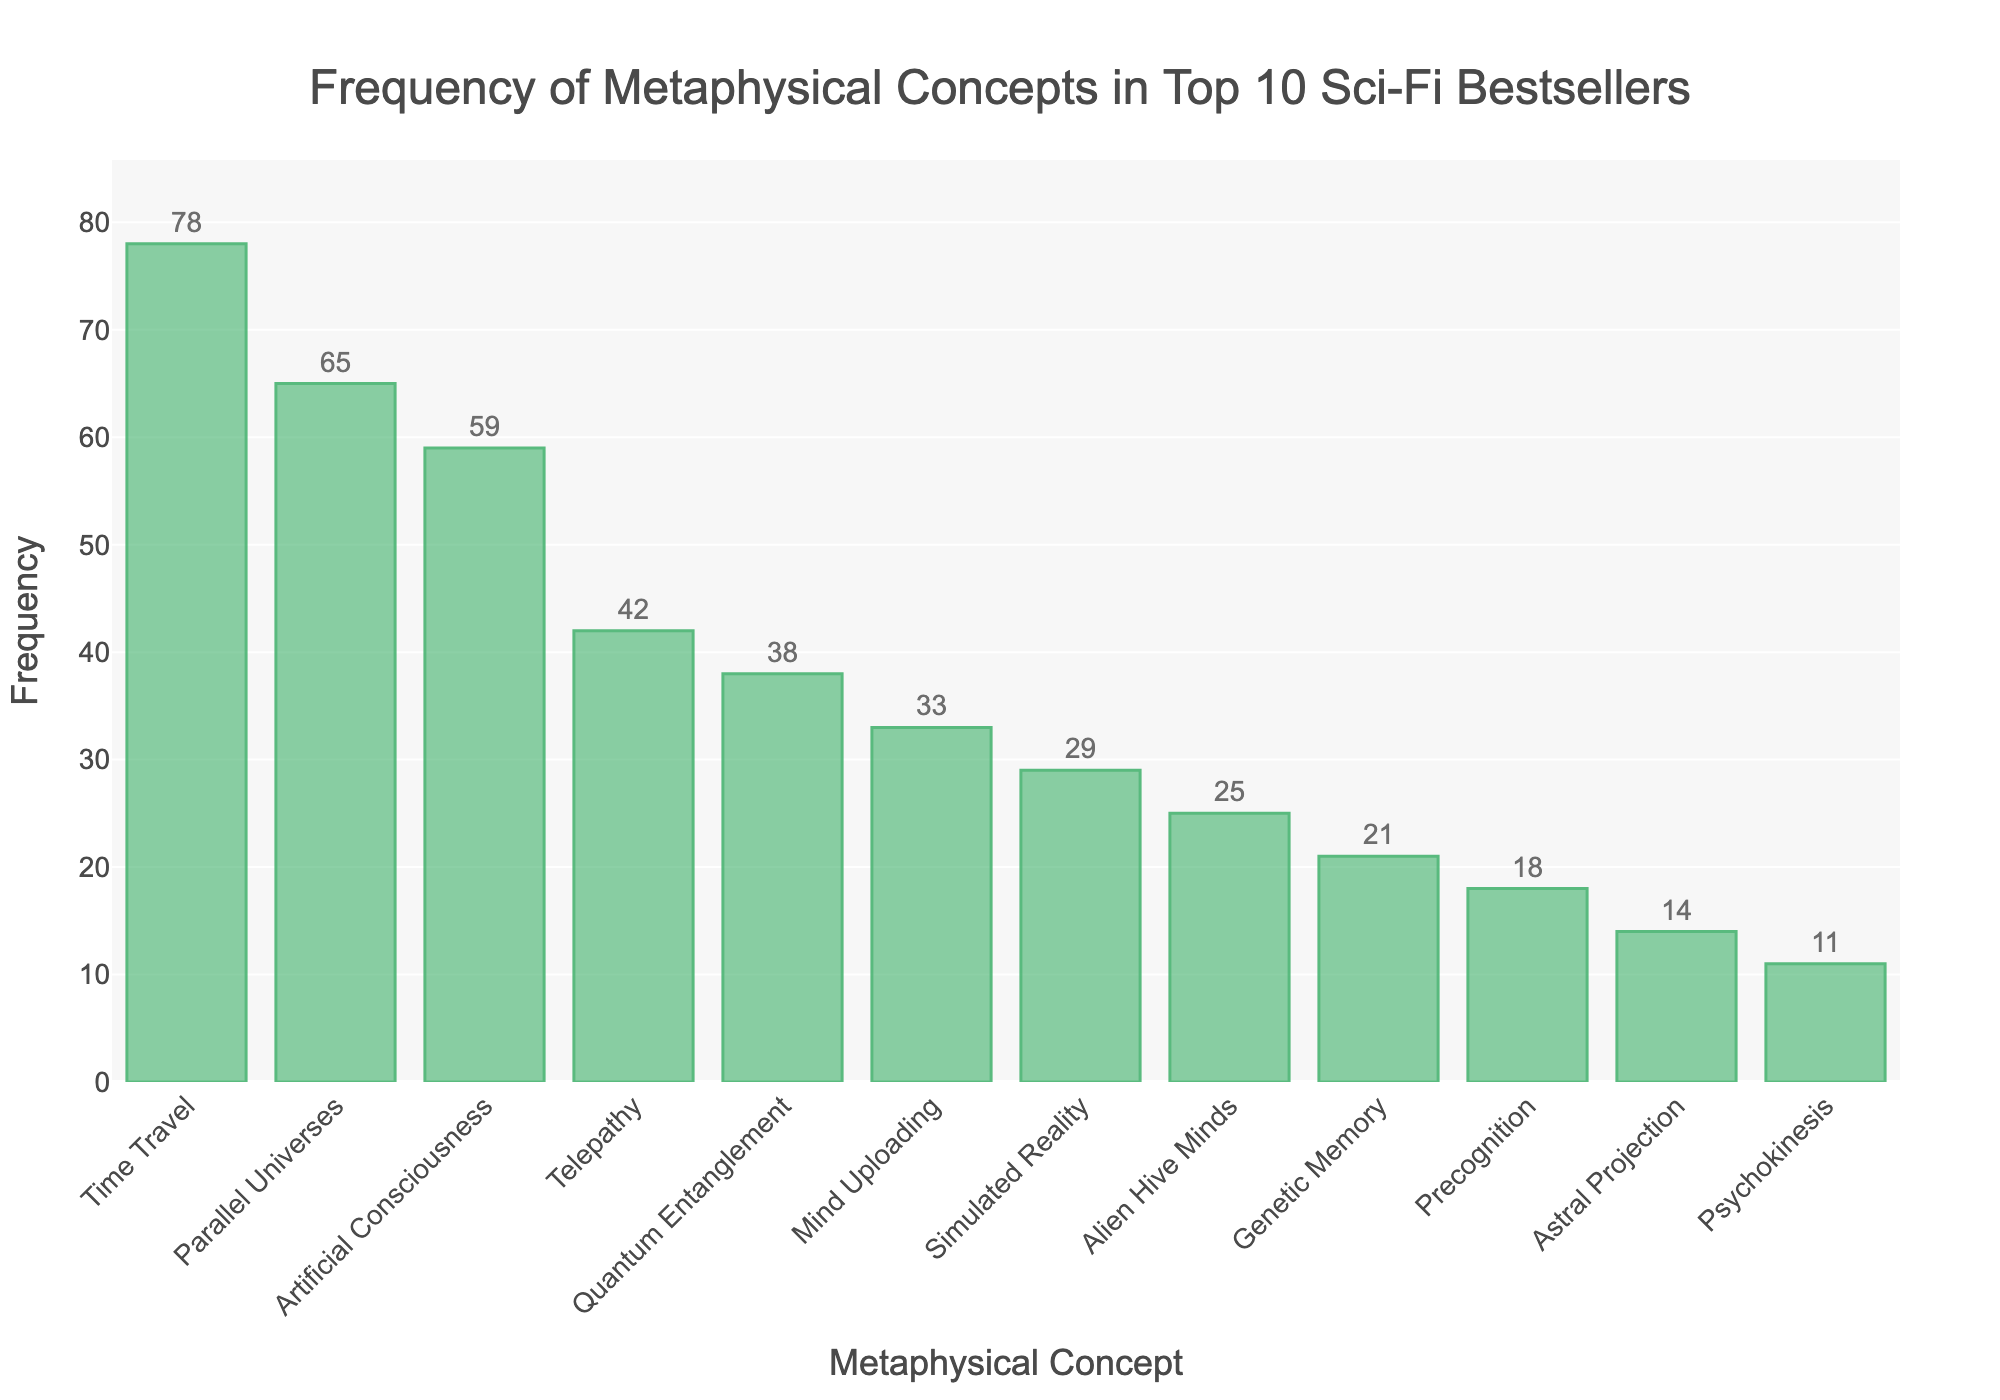Which metaphysical concept appears most frequently in the top 10 sci-fi bestsellers? The bar representing "Time Travel" is the highest on the chart indicating it appears most frequently.
Answer: Time Travel Which concept is more frequent, "Telepathy" or "Quantum Entanglement"? By comparing the heights of the bars, "Telepathy" has a frequency of 42 while "Quantum Entanglement" has a frequency of 38.
Answer: Telepathy How much more frequent is "Artificial Consciousness" compared to "Simulated Reality"? The bar for "Artificial Consciousness" is at 59 and "Simulated Reality" is at 29. The difference is 59 - 29.
Answer: 30 What is the total frequency of "Mind Uploading" and "Genetic Memory" combined? "Mind Uploading" has a frequency of 33 and "Genetic Memory" has a frequency of 21. Adding them gives 33 + 21.
Answer: 54 What is the average frequency of "Astral Projection", "Psychokinesis", and "Precognition"? Summing their frequencies: 14 (Astral Projection) + 11 (Psychokinesis) + 18 (Precognition) = 43. There are 3 concepts, so the average is 43 / 3.
Answer: 14.33 Which concept is least frequent in the chart? The shortest bar on the chart is for "Psychokinesis" with a frequency of 11.
Answer: Psychokinesis Are there more concepts with frequencies above or below 30? The concepts with frequencies above 30 are 6 (Time Travel, Parallel Universes, Artificial Consciousness, Telepathy, Quantum Entanglement, Mind Uploading). Concepts with frequencies below 30 are 6 (Simulated Reality, Alien Hive Minds, Genetic Memory, Precognition, Astral Projection, Psychokinesis).
Answer: Equal 